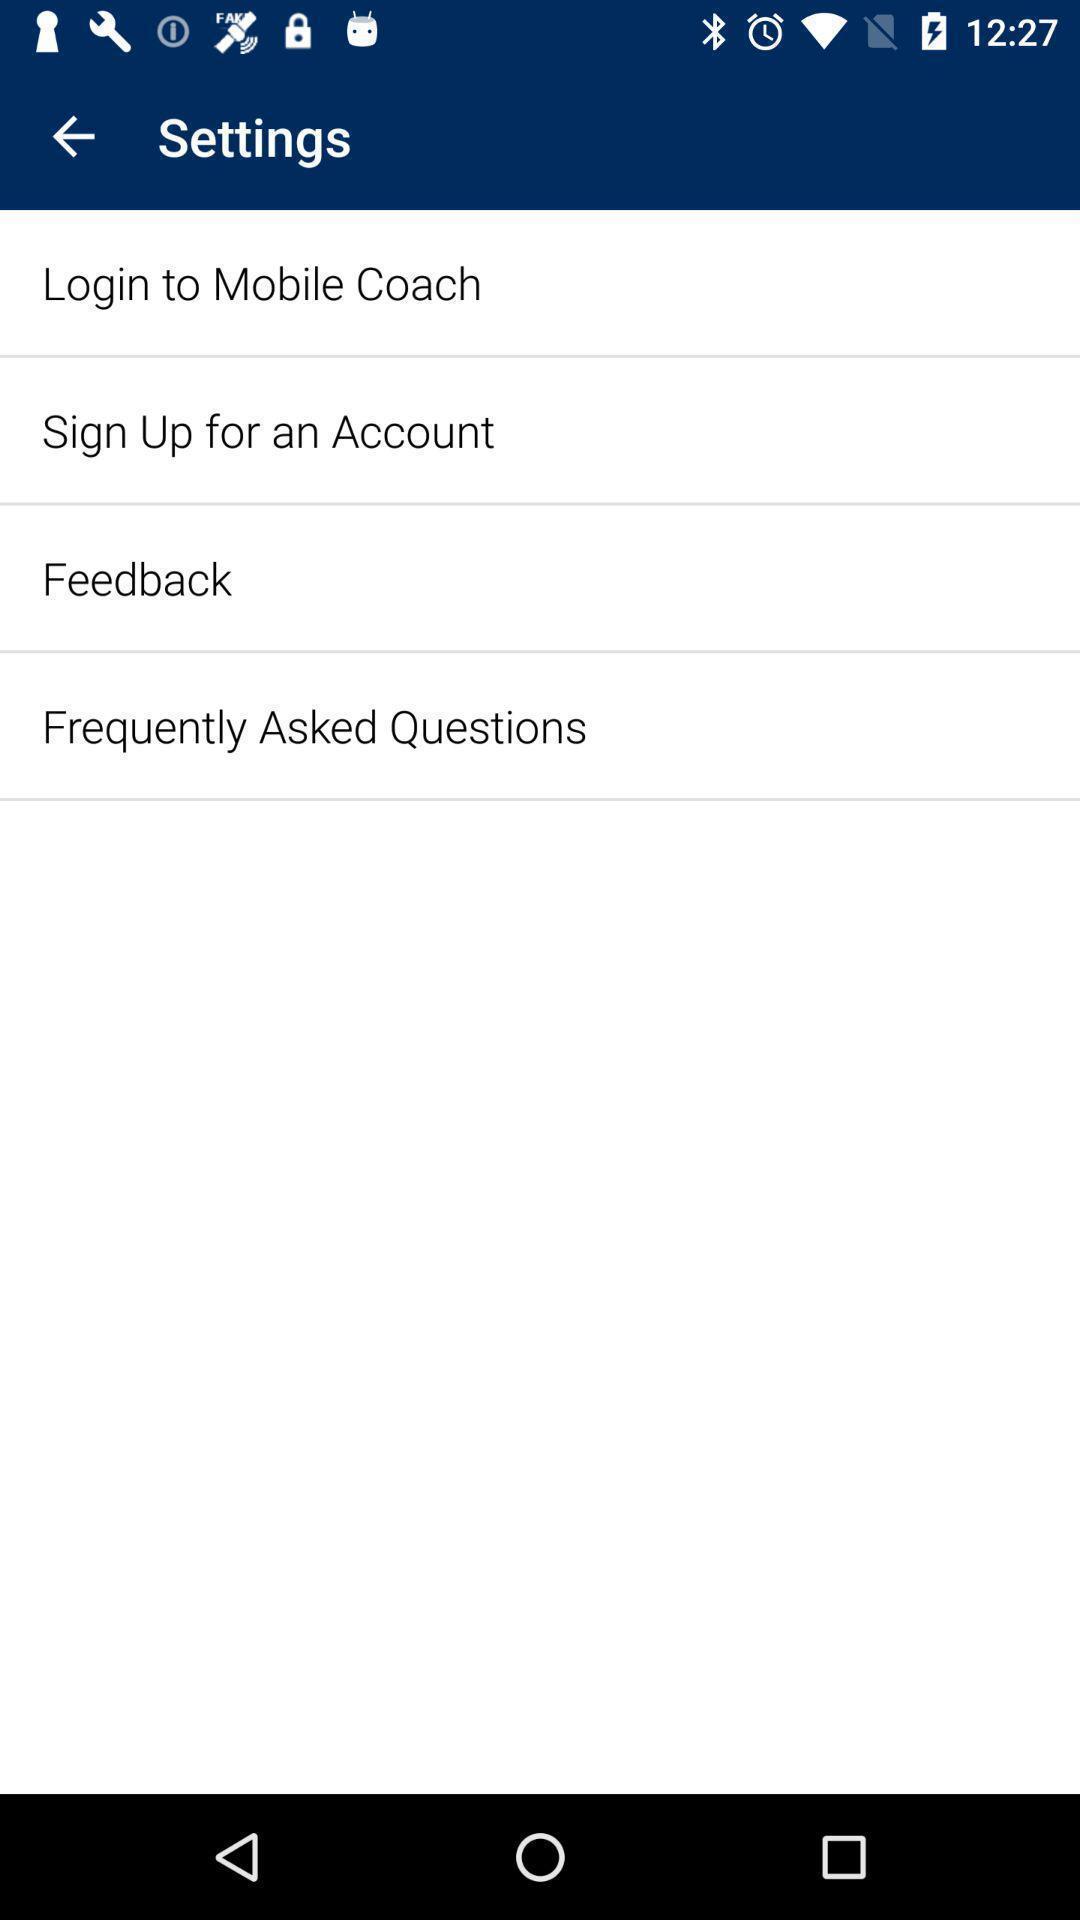Describe this image in words. Settings page with options. 